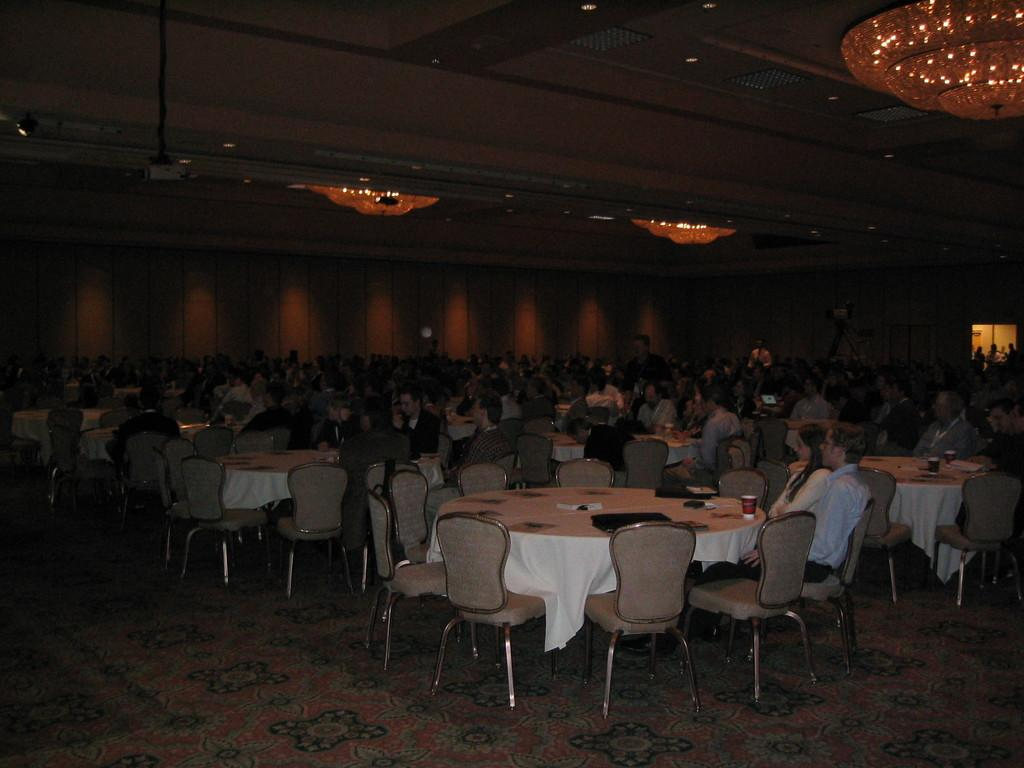What type of setting is shown in the image? The image appears to depict a dining hall. What kind of table is in the image? There is a round table in the image. What are the people doing in the image? A group of people are sitting around the table. What are the people sitting on in the image? The people are sitting on chairs. How many islands can be seen in the image? There are no islands present in the image; it depicts a dining hall with a round table and chairs. 